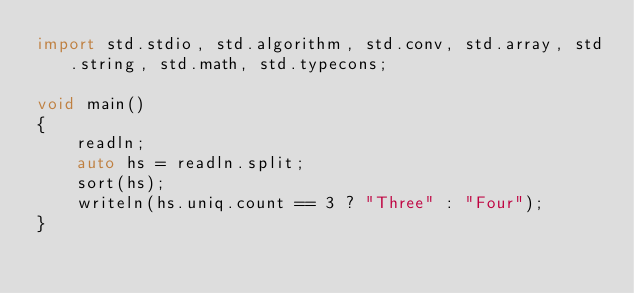Convert code to text. <code><loc_0><loc_0><loc_500><loc_500><_D_>import std.stdio, std.algorithm, std.conv, std.array, std.string, std.math, std.typecons;

void main()
{
    readln;
    auto hs = readln.split;
    sort(hs);
    writeln(hs.uniq.count == 3 ? "Three" : "Four");
}</code> 